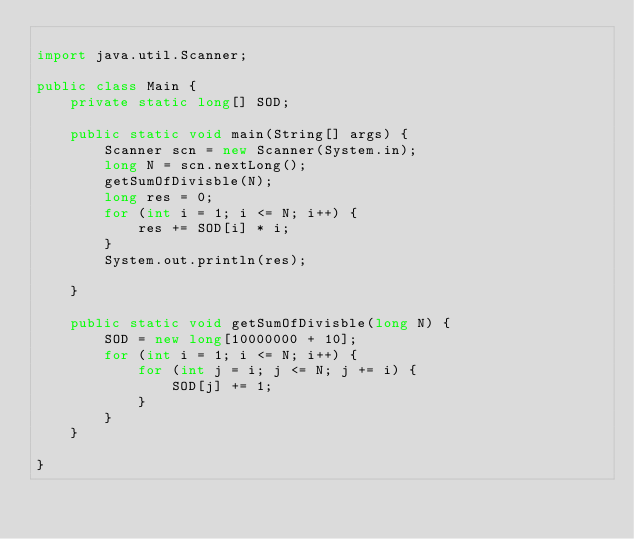<code> <loc_0><loc_0><loc_500><loc_500><_Java_>
import java.util.Scanner;

public class Main {
    private static long[] SOD;

    public static void main(String[] args) {
        Scanner scn = new Scanner(System.in);
        long N = scn.nextLong();
        getSumOfDivisble(N);
        long res = 0;
        for (int i = 1; i <= N; i++) {
            res += SOD[i] * i;
        }
        System.out.println(res);

    }

    public static void getSumOfDivisble(long N) {
        SOD = new long[10000000 + 10];
        for (int i = 1; i <= N; i++) {
            for (int j = i; j <= N; j += i) {
                SOD[j] += 1;
            }
        }
    }

}</code> 